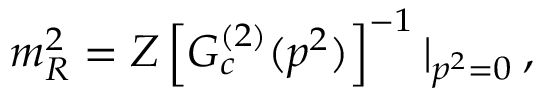Convert formula to latex. <formula><loc_0><loc_0><loc_500><loc_500>m _ { R } ^ { 2 } = Z \left [ G _ { c } ^ { ( 2 ) } ( p ^ { 2 } ) \right ] ^ { - 1 } | _ { p ^ { 2 } = 0 } \, ,</formula> 